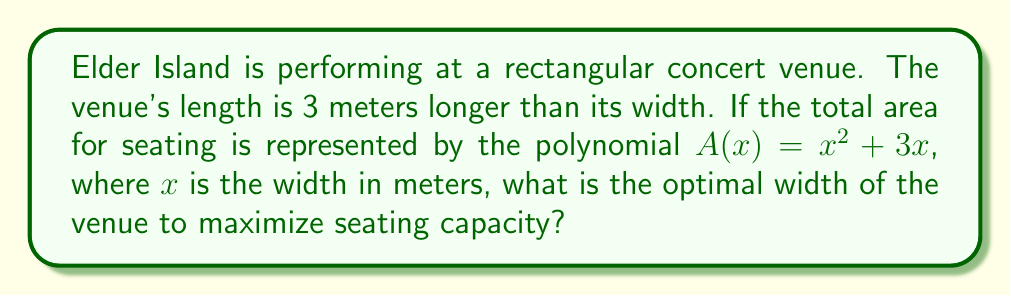What is the answer to this math problem? Let's approach this step-by-step:

1) We're given that $A(x) = x^2 + 3x$, where $x$ is the width of the venue.

2) To find the maximum value of $A(x)$, we need to find the vertex of this parabola. The vertex represents the point where the area is maximized.

3) For a quadratic function in the form $f(x) = ax^2 + bx + c$, the x-coordinate of the vertex is given by $x = -\frac{b}{2a}$.

4) In our case, $a = 1$ and $b = 3$. So:

   $x = -\frac{3}{2(1)} = -\frac{3}{2}$

5) However, since we're dealing with physical dimensions, we need the positive value. The parabola is symmetric, so the positive x-value that gives the same maximum is:

   $x = \frac{3}{2} = 1.5$

6) We can verify this by taking the derivative of $A(x)$ and setting it to zero:

   $A'(x) = 2x + 3$
   $0 = 2x + 3$
   $x = -\frac{3}{2}$

   This confirms our result.

Therefore, the optimal width of the venue is 1.5 meters.
Answer: 1.5 meters 